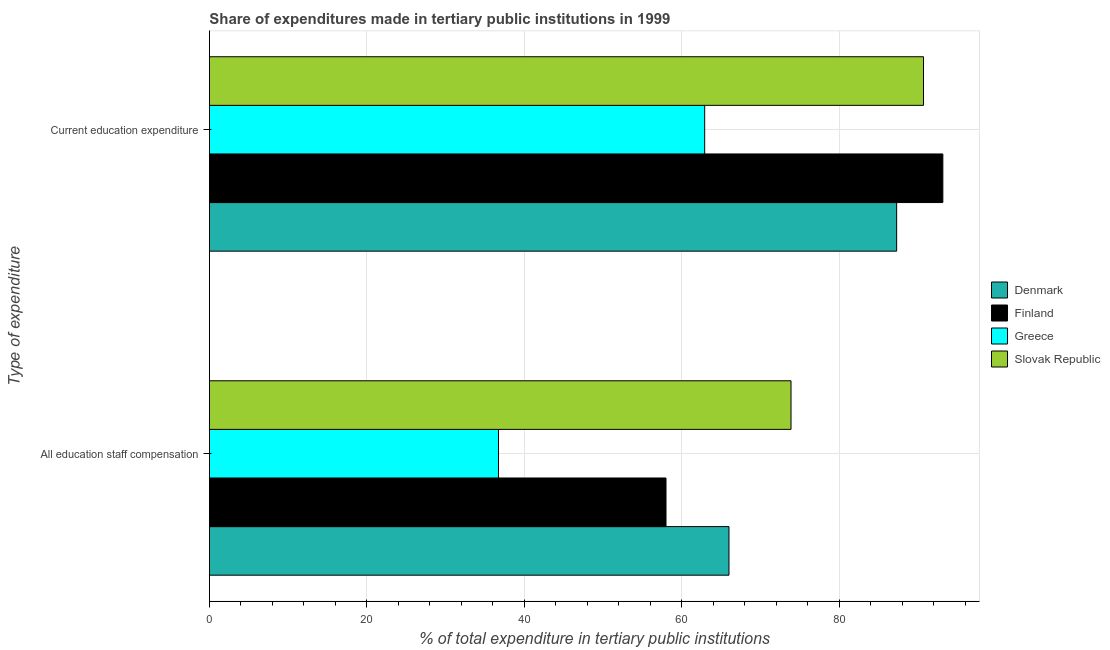How many different coloured bars are there?
Provide a succinct answer. 4. Are the number of bars per tick equal to the number of legend labels?
Your answer should be compact. Yes. Are the number of bars on each tick of the Y-axis equal?
Provide a short and direct response. Yes. What is the label of the 1st group of bars from the top?
Ensure brevity in your answer.  Current education expenditure. What is the expenditure in education in Greece?
Offer a very short reply. 62.91. Across all countries, what is the maximum expenditure in staff compensation?
Give a very brief answer. 73.88. Across all countries, what is the minimum expenditure in education?
Give a very brief answer. 62.91. In which country was the expenditure in education maximum?
Give a very brief answer. Finland. In which country was the expenditure in staff compensation minimum?
Your answer should be very brief. Greece. What is the total expenditure in staff compensation in the graph?
Your answer should be very brief. 234.61. What is the difference between the expenditure in staff compensation in Finland and that in Denmark?
Give a very brief answer. -8. What is the difference between the expenditure in education in Greece and the expenditure in staff compensation in Finland?
Give a very brief answer. 4.91. What is the average expenditure in staff compensation per country?
Provide a succinct answer. 58.65. What is the difference between the expenditure in staff compensation and expenditure in education in Greece?
Your response must be concise. -26.19. In how many countries, is the expenditure in education greater than 28 %?
Ensure brevity in your answer.  4. What is the ratio of the expenditure in staff compensation in Denmark to that in Slovak Republic?
Offer a very short reply. 0.89. Is the expenditure in education in Finland less than that in Slovak Republic?
Your answer should be very brief. No. What does the 2nd bar from the bottom in Current education expenditure represents?
Keep it short and to the point. Finland. Are all the bars in the graph horizontal?
Offer a very short reply. Yes. Are the values on the major ticks of X-axis written in scientific E-notation?
Offer a very short reply. No. Does the graph contain grids?
Ensure brevity in your answer.  Yes. Where does the legend appear in the graph?
Keep it short and to the point. Center right. How many legend labels are there?
Provide a succinct answer. 4. What is the title of the graph?
Offer a very short reply. Share of expenditures made in tertiary public institutions in 1999. Does "Uzbekistan" appear as one of the legend labels in the graph?
Your answer should be compact. No. What is the label or title of the X-axis?
Ensure brevity in your answer.  % of total expenditure in tertiary public institutions. What is the label or title of the Y-axis?
Provide a succinct answer. Type of expenditure. What is the % of total expenditure in tertiary public institutions in Denmark in All education staff compensation?
Keep it short and to the point. 66. What is the % of total expenditure in tertiary public institutions of Finland in All education staff compensation?
Your answer should be compact. 58. What is the % of total expenditure in tertiary public institutions in Greece in All education staff compensation?
Offer a terse response. 36.72. What is the % of total expenditure in tertiary public institutions in Slovak Republic in All education staff compensation?
Ensure brevity in your answer.  73.88. What is the % of total expenditure in tertiary public institutions of Denmark in Current education expenditure?
Offer a terse response. 87.3. What is the % of total expenditure in tertiary public institutions of Finland in Current education expenditure?
Offer a very short reply. 93.17. What is the % of total expenditure in tertiary public institutions in Greece in Current education expenditure?
Provide a succinct answer. 62.91. What is the % of total expenditure in tertiary public institutions of Slovak Republic in Current education expenditure?
Provide a succinct answer. 90.71. Across all Type of expenditure, what is the maximum % of total expenditure in tertiary public institutions in Denmark?
Your answer should be compact. 87.3. Across all Type of expenditure, what is the maximum % of total expenditure in tertiary public institutions in Finland?
Your response must be concise. 93.17. Across all Type of expenditure, what is the maximum % of total expenditure in tertiary public institutions in Greece?
Make the answer very short. 62.91. Across all Type of expenditure, what is the maximum % of total expenditure in tertiary public institutions of Slovak Republic?
Ensure brevity in your answer.  90.71. Across all Type of expenditure, what is the minimum % of total expenditure in tertiary public institutions in Denmark?
Offer a terse response. 66. Across all Type of expenditure, what is the minimum % of total expenditure in tertiary public institutions of Finland?
Ensure brevity in your answer.  58. Across all Type of expenditure, what is the minimum % of total expenditure in tertiary public institutions in Greece?
Your response must be concise. 36.72. Across all Type of expenditure, what is the minimum % of total expenditure in tertiary public institutions in Slovak Republic?
Offer a very short reply. 73.88. What is the total % of total expenditure in tertiary public institutions of Denmark in the graph?
Offer a very short reply. 153.3. What is the total % of total expenditure in tertiary public institutions of Finland in the graph?
Your response must be concise. 151.17. What is the total % of total expenditure in tertiary public institutions in Greece in the graph?
Your answer should be very brief. 99.64. What is the total % of total expenditure in tertiary public institutions of Slovak Republic in the graph?
Keep it short and to the point. 164.59. What is the difference between the % of total expenditure in tertiary public institutions of Denmark in All education staff compensation and that in Current education expenditure?
Make the answer very short. -21.3. What is the difference between the % of total expenditure in tertiary public institutions of Finland in All education staff compensation and that in Current education expenditure?
Offer a very short reply. -35.17. What is the difference between the % of total expenditure in tertiary public institutions of Greece in All education staff compensation and that in Current education expenditure?
Offer a very short reply. -26.19. What is the difference between the % of total expenditure in tertiary public institutions in Slovak Republic in All education staff compensation and that in Current education expenditure?
Provide a succinct answer. -16.83. What is the difference between the % of total expenditure in tertiary public institutions of Denmark in All education staff compensation and the % of total expenditure in tertiary public institutions of Finland in Current education expenditure?
Give a very brief answer. -27.16. What is the difference between the % of total expenditure in tertiary public institutions of Denmark in All education staff compensation and the % of total expenditure in tertiary public institutions of Greece in Current education expenditure?
Keep it short and to the point. 3.09. What is the difference between the % of total expenditure in tertiary public institutions of Denmark in All education staff compensation and the % of total expenditure in tertiary public institutions of Slovak Republic in Current education expenditure?
Ensure brevity in your answer.  -24.71. What is the difference between the % of total expenditure in tertiary public institutions in Finland in All education staff compensation and the % of total expenditure in tertiary public institutions in Greece in Current education expenditure?
Your answer should be very brief. -4.91. What is the difference between the % of total expenditure in tertiary public institutions in Finland in All education staff compensation and the % of total expenditure in tertiary public institutions in Slovak Republic in Current education expenditure?
Offer a terse response. -32.71. What is the difference between the % of total expenditure in tertiary public institutions in Greece in All education staff compensation and the % of total expenditure in tertiary public institutions in Slovak Republic in Current education expenditure?
Offer a very short reply. -53.99. What is the average % of total expenditure in tertiary public institutions of Denmark per Type of expenditure?
Make the answer very short. 76.65. What is the average % of total expenditure in tertiary public institutions in Finland per Type of expenditure?
Keep it short and to the point. 75.58. What is the average % of total expenditure in tertiary public institutions in Greece per Type of expenditure?
Your answer should be very brief. 49.82. What is the average % of total expenditure in tertiary public institutions of Slovak Republic per Type of expenditure?
Provide a succinct answer. 82.3. What is the difference between the % of total expenditure in tertiary public institutions in Denmark and % of total expenditure in tertiary public institutions in Finland in All education staff compensation?
Make the answer very short. 8. What is the difference between the % of total expenditure in tertiary public institutions in Denmark and % of total expenditure in tertiary public institutions in Greece in All education staff compensation?
Your response must be concise. 29.28. What is the difference between the % of total expenditure in tertiary public institutions in Denmark and % of total expenditure in tertiary public institutions in Slovak Republic in All education staff compensation?
Ensure brevity in your answer.  -7.88. What is the difference between the % of total expenditure in tertiary public institutions of Finland and % of total expenditure in tertiary public institutions of Greece in All education staff compensation?
Make the answer very short. 21.28. What is the difference between the % of total expenditure in tertiary public institutions in Finland and % of total expenditure in tertiary public institutions in Slovak Republic in All education staff compensation?
Make the answer very short. -15.88. What is the difference between the % of total expenditure in tertiary public institutions of Greece and % of total expenditure in tertiary public institutions of Slovak Republic in All education staff compensation?
Provide a short and direct response. -37.16. What is the difference between the % of total expenditure in tertiary public institutions in Denmark and % of total expenditure in tertiary public institutions in Finland in Current education expenditure?
Make the answer very short. -5.87. What is the difference between the % of total expenditure in tertiary public institutions in Denmark and % of total expenditure in tertiary public institutions in Greece in Current education expenditure?
Provide a short and direct response. 24.39. What is the difference between the % of total expenditure in tertiary public institutions of Denmark and % of total expenditure in tertiary public institutions of Slovak Republic in Current education expenditure?
Offer a very short reply. -3.41. What is the difference between the % of total expenditure in tertiary public institutions of Finland and % of total expenditure in tertiary public institutions of Greece in Current education expenditure?
Keep it short and to the point. 30.25. What is the difference between the % of total expenditure in tertiary public institutions in Finland and % of total expenditure in tertiary public institutions in Slovak Republic in Current education expenditure?
Your response must be concise. 2.45. What is the difference between the % of total expenditure in tertiary public institutions in Greece and % of total expenditure in tertiary public institutions in Slovak Republic in Current education expenditure?
Give a very brief answer. -27.8. What is the ratio of the % of total expenditure in tertiary public institutions of Denmark in All education staff compensation to that in Current education expenditure?
Your answer should be compact. 0.76. What is the ratio of the % of total expenditure in tertiary public institutions of Finland in All education staff compensation to that in Current education expenditure?
Offer a very short reply. 0.62. What is the ratio of the % of total expenditure in tertiary public institutions of Greece in All education staff compensation to that in Current education expenditure?
Your answer should be compact. 0.58. What is the ratio of the % of total expenditure in tertiary public institutions of Slovak Republic in All education staff compensation to that in Current education expenditure?
Provide a short and direct response. 0.81. What is the difference between the highest and the second highest % of total expenditure in tertiary public institutions of Denmark?
Provide a succinct answer. 21.3. What is the difference between the highest and the second highest % of total expenditure in tertiary public institutions in Finland?
Your answer should be very brief. 35.17. What is the difference between the highest and the second highest % of total expenditure in tertiary public institutions of Greece?
Your answer should be compact. 26.19. What is the difference between the highest and the second highest % of total expenditure in tertiary public institutions of Slovak Republic?
Make the answer very short. 16.83. What is the difference between the highest and the lowest % of total expenditure in tertiary public institutions in Denmark?
Offer a terse response. 21.3. What is the difference between the highest and the lowest % of total expenditure in tertiary public institutions in Finland?
Ensure brevity in your answer.  35.17. What is the difference between the highest and the lowest % of total expenditure in tertiary public institutions of Greece?
Offer a terse response. 26.19. What is the difference between the highest and the lowest % of total expenditure in tertiary public institutions of Slovak Republic?
Provide a short and direct response. 16.83. 